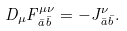<formula> <loc_0><loc_0><loc_500><loc_500>D _ { \mu } F ^ { \mu \nu } _ { \bar { a } \bar { b } } = - J ^ { \nu } _ { \bar { a } \bar { b } } .</formula> 